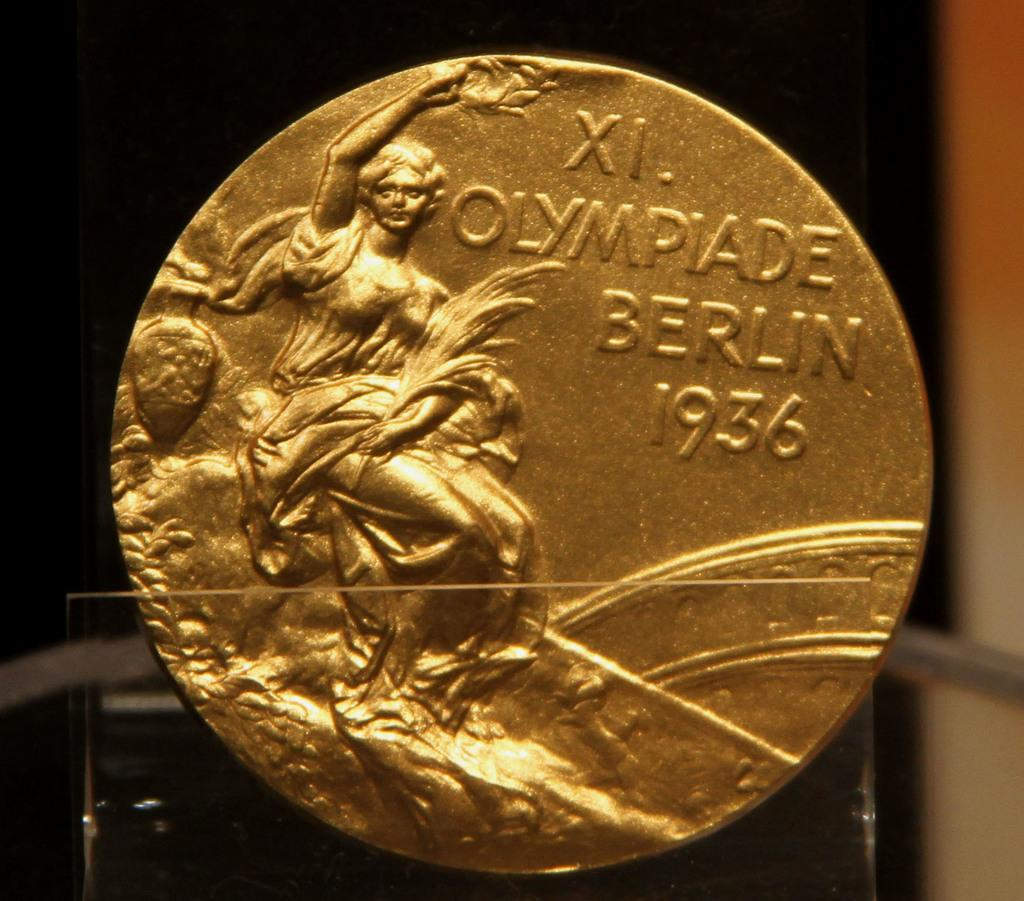Provide a one-sentence caption for the provided image. A Xi. Olympiade Berlin 1936 Olympic gold medal from the Berlin Olympic Games. 